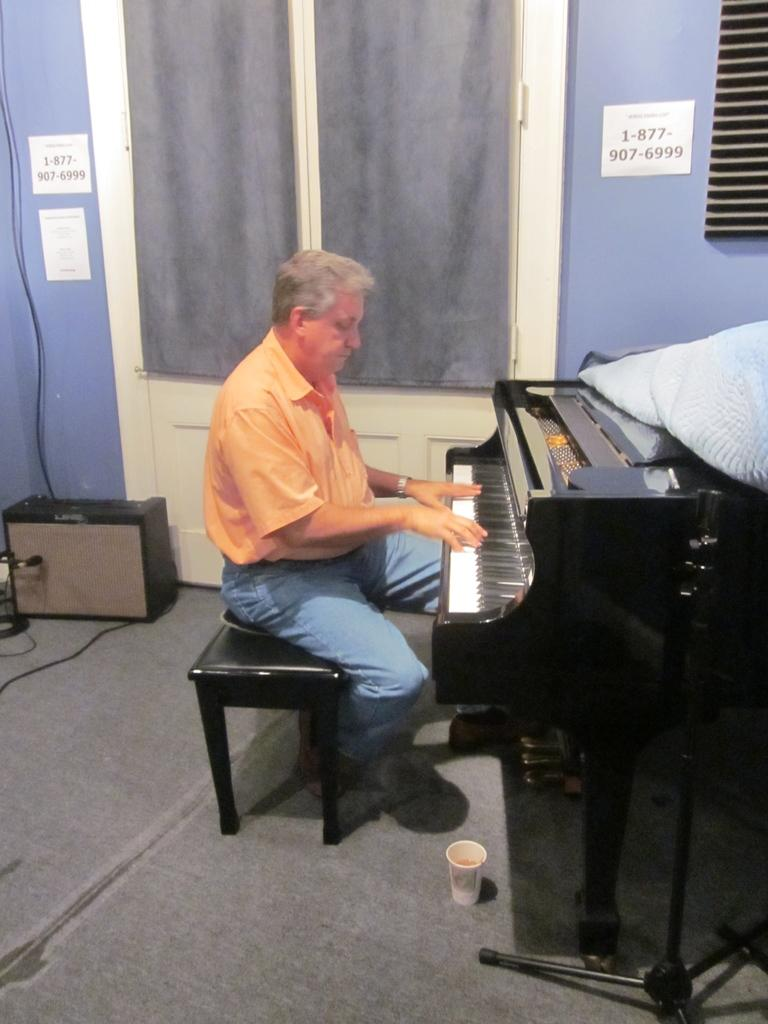Who is the person in the image? There is a man in the image. What is the man wearing? The man is wearing an orange shirt. What is the man doing in the image? The man is sitting on a table and playing a piano. What can be seen in the background of the image? There is a door visible in the background of the image. What type of drink is the man holding in the image? There is no drink visible in the image; the man is playing a piano while sitting on a table. 